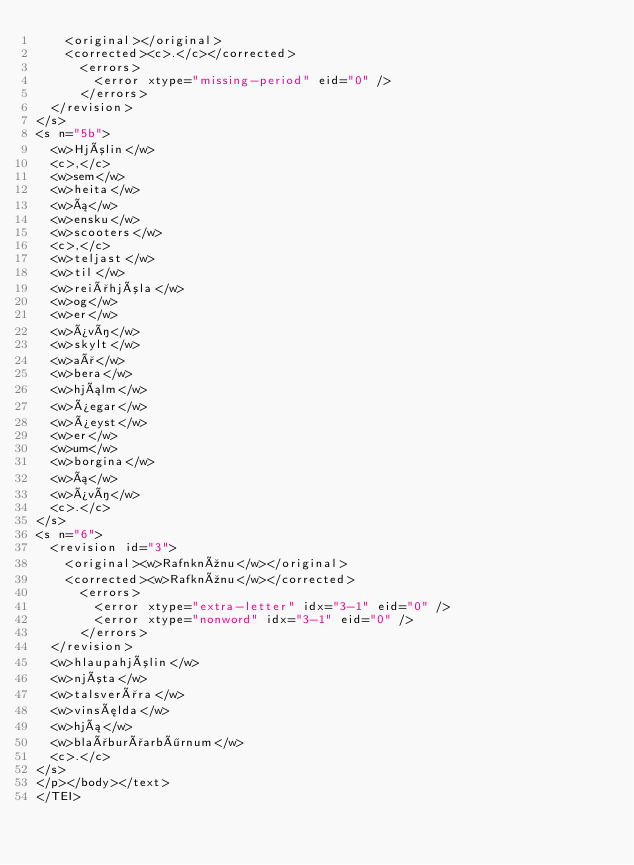Convert code to text. <code><loc_0><loc_0><loc_500><loc_500><_XML_>    <original></original>
    <corrected><c>.</c></corrected>
      <errors>
        <error xtype="missing-period" eid="0" />
      </errors>
  </revision>
</s>
<s n="5b">
  <w>Hjólin</w>
  <c>,</c>
  <w>sem</w>
  <w>heita</w>
  <w>á</w>
  <w>ensku</w>
  <w>scooters</w>
  <c>,</c>
  <w>teljast</w>
  <w>til</w>
  <w>reiðhjóla</w>
  <w>og</w>
  <w>er</w>
  <w>því</w>
  <w>skylt</w>
  <w>að</w>
  <w>bera</w>
  <w>hjálm</w>
  <w>þegar</w>
  <w>þeyst</w>
  <w>er</w>
  <w>um</w>
  <w>borgina</w>
  <w>á</w>
  <w>því</w>
  <c>.</c>
</s>
<s n="6">
  <revision id="3">
    <original><w>Rafnknúnu</w></original>
    <corrected><w>Rafknúnu</w></corrected>
      <errors>
        <error xtype="extra-letter" idx="3-1" eid="0" />
        <error xtype="nonword" idx="3-1" eid="0" />
      </errors>
  </revision>
  <w>hlaupahjólin</w>
  <w>njóta</w>
  <w>talsverðra</w>
  <w>vinsælda</w>
  <w>hjá</w>
  <w>blaðburðarbörnum</w>
  <c>.</c>
</s>
</p></body></text>
</TEI></code> 